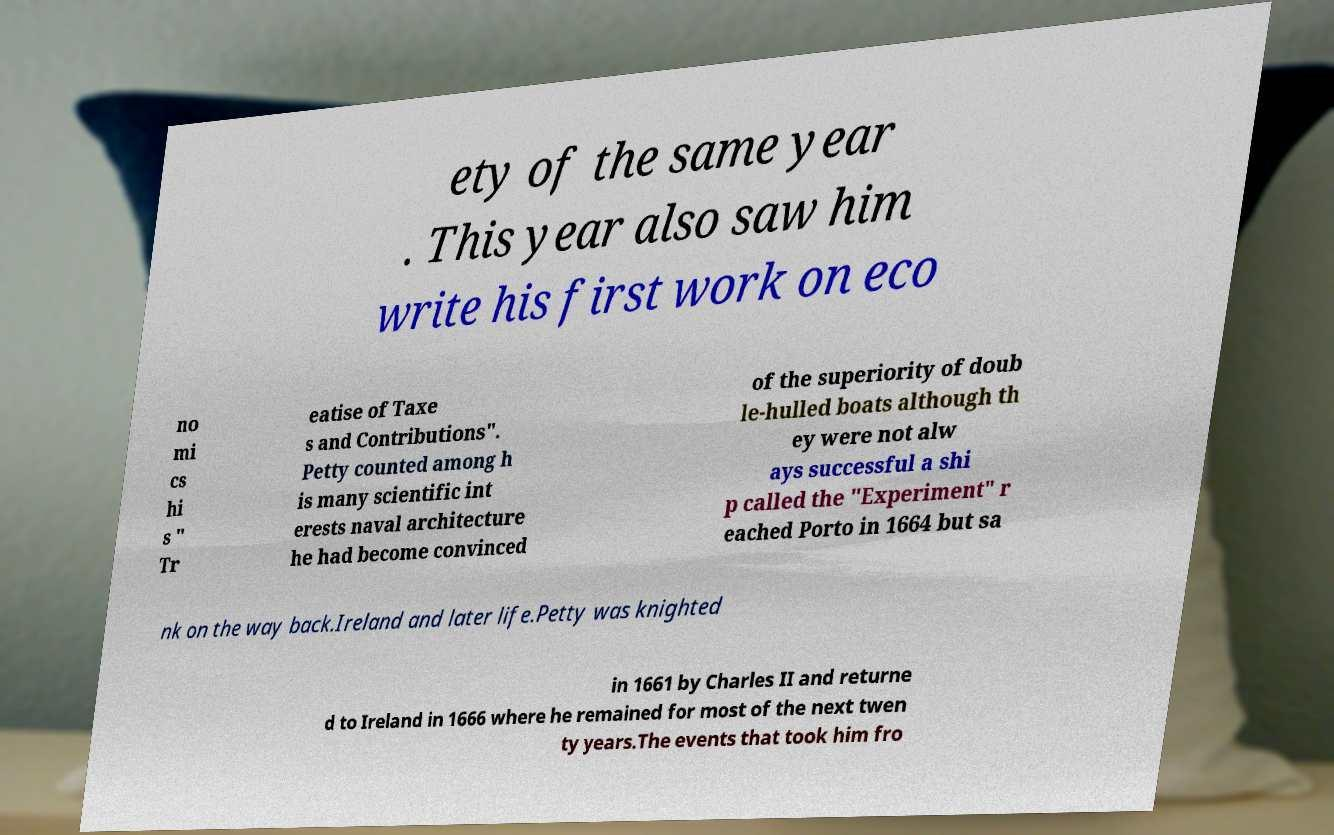For documentation purposes, I need the text within this image transcribed. Could you provide that? ety of the same year . This year also saw him write his first work on eco no mi cs hi s " Tr eatise of Taxe s and Contributions". Petty counted among h is many scientific int erests naval architecture he had become convinced of the superiority of doub le-hulled boats although th ey were not alw ays successful a shi p called the "Experiment" r eached Porto in 1664 but sa nk on the way back.Ireland and later life.Petty was knighted in 1661 by Charles II and returne d to Ireland in 1666 where he remained for most of the next twen ty years.The events that took him fro 